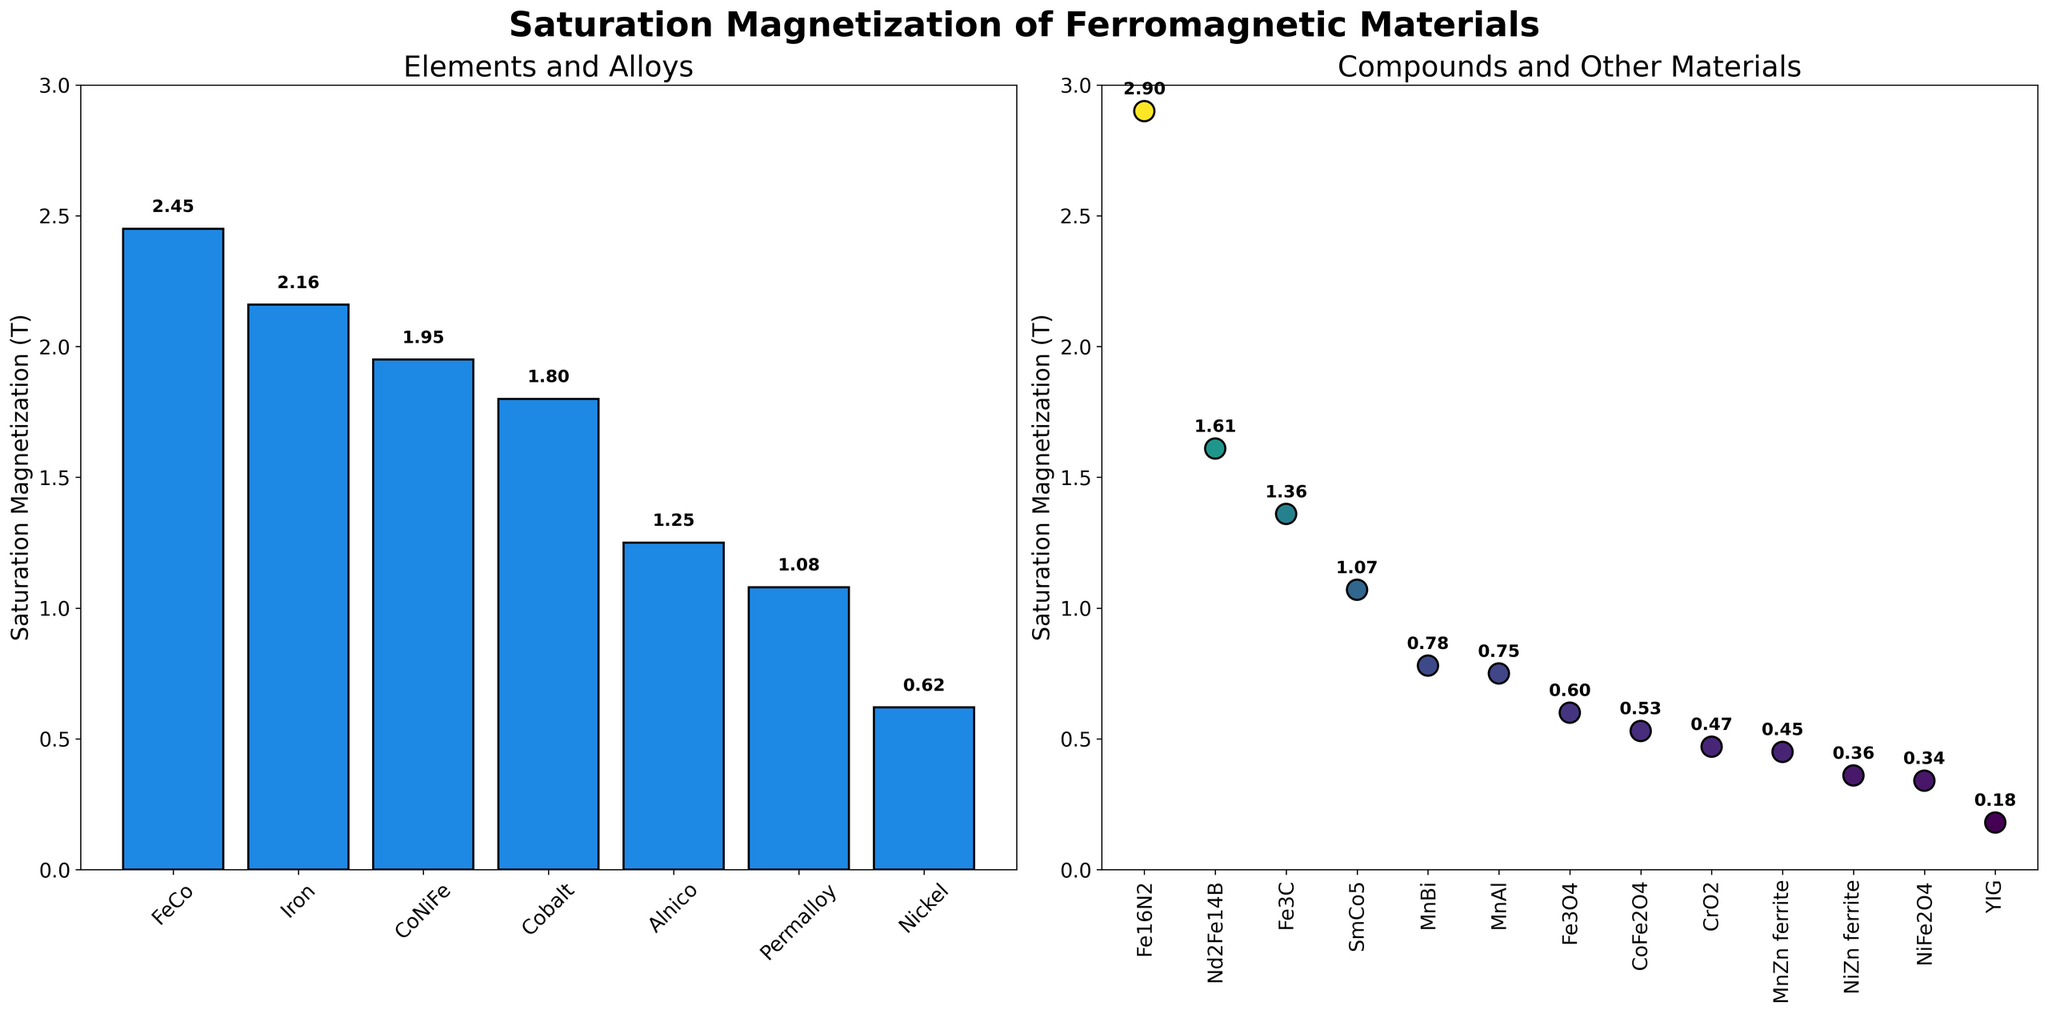Which element or alloy has the highest saturation magnetization value in the first subplot? In the first subplot, compare the heights of the bars. The tallest bar belongs to FeCo.
Answer: FeCo Which compound or other material has the lowest saturation magnetization value in the second subplot? In the second subplot, compare the positions of the scatter points. The lowest scatter point belongs to YIG.
Answer: YIG What is the difference in saturation magnetization between Iron and Nickel in the first subplot? Iron's saturation magnetization is 2.16 T and Nickel's is 0.62 T. The difference is 2.16 - 0.62 = 1.54 T.
Answer: 1.54 T How many materials in the second subplot have a saturation magnetization greater than 1 T? In the second subplot, scan for scatter points with values above 1 T. These are Nd2Fe14B and Fe16N2, meaning there are 2 materials.
Answer: 2 What is the average saturation magnetization value of Alnico and Permalloy from the first subplot? Alnico's saturation magnetization is 1.25 T and Permalloy's is 1.08 T. The average is (1.25 + 1.08) / 2 = 2.33 / 2 = 1.165 T.
Answer: 1.165 T Which material in the first subplot has the closest saturation magnetization value to 2 T? Compare the saturation magnetization values to 2 T. CoNiFe has a value of 1.95 T, which is closest to 2 T.
Answer: CoNiFe Which compound or other material shows a saturation magnetization value between 0.5 T and 1 T in the second subplot? Scan the second subplot for values within the range 0.5 T to 1 T. These materials are Fe3O4, MnBi, and CoFe2O4.
Answer: Fe3O4, MnBi, CoFe2O4 